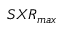<formula> <loc_0><loc_0><loc_500><loc_500>S X R _ { \max }</formula> 